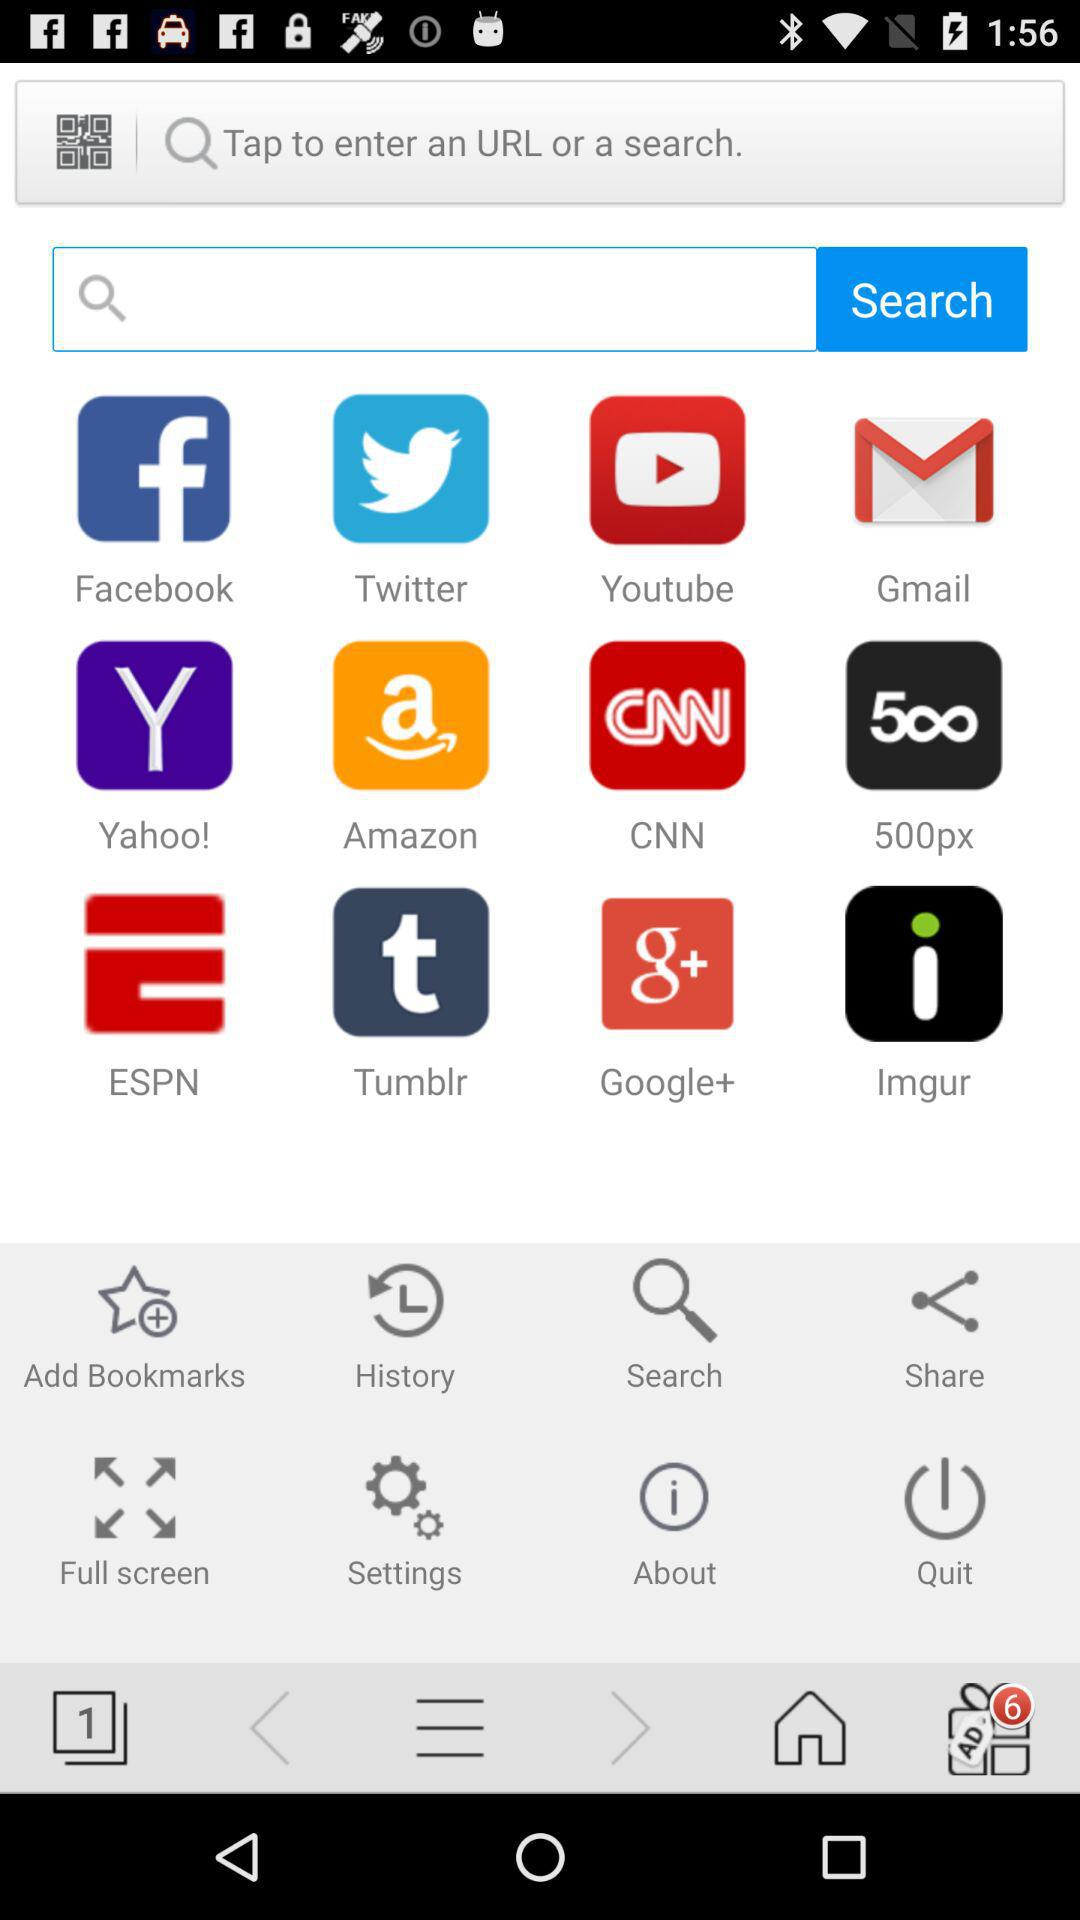What is written in the search bar?
When the provided information is insufficient, respond with <no answer>. <no answer> 